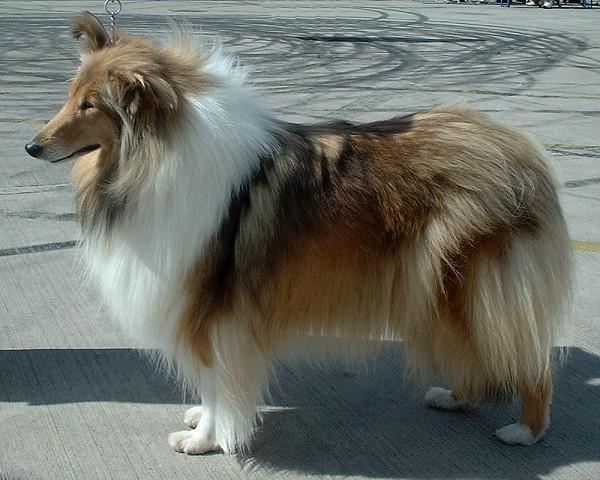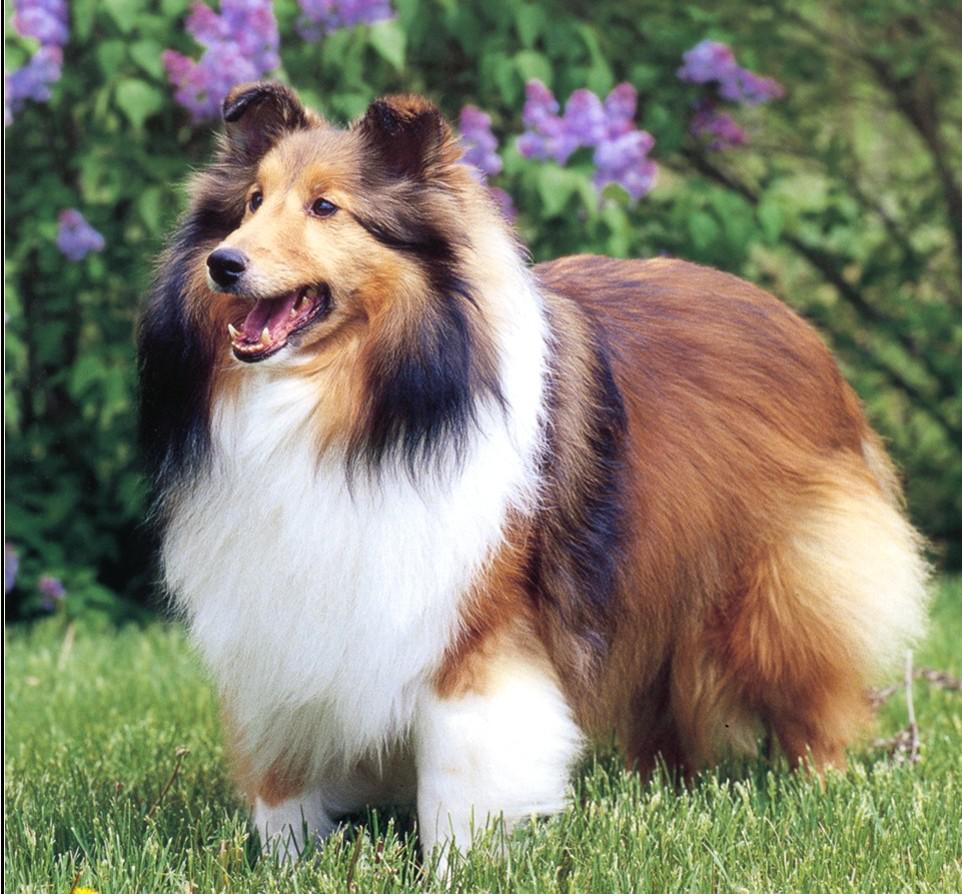The first image is the image on the left, the second image is the image on the right. For the images displayed, is the sentence "One fluffy dog is standing in the grass near flowers." factually correct? Answer yes or no. Yes. The first image is the image on the left, the second image is the image on the right. Analyze the images presented: Is the assertion "The right image shows a collie posed on green grass." valid? Answer yes or no. Yes. The first image is the image on the left, the second image is the image on the right. Given the left and right images, does the statement "in at least one image there is a dog standing in the grass" hold true? Answer yes or no. Yes. 